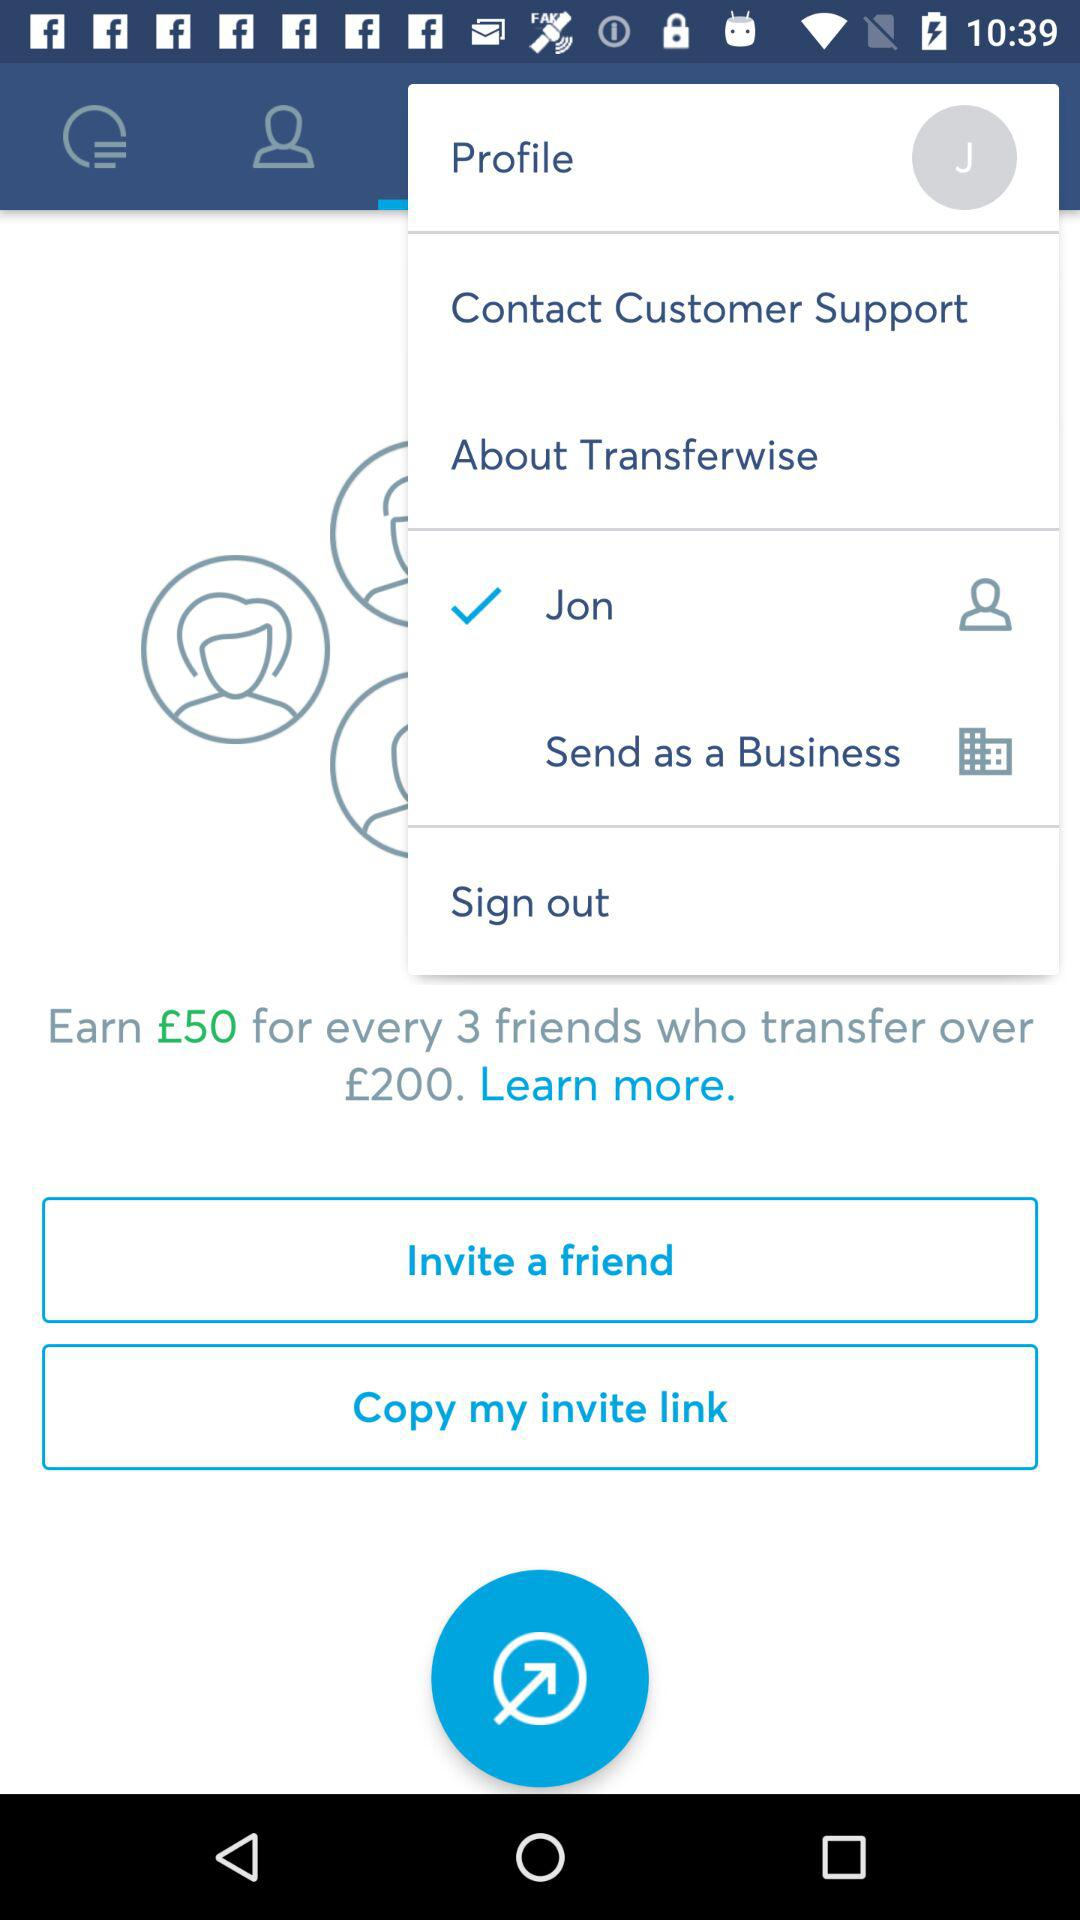How much money should friends transfer? The amount of money that friends should transfer is £200. 